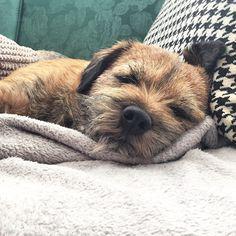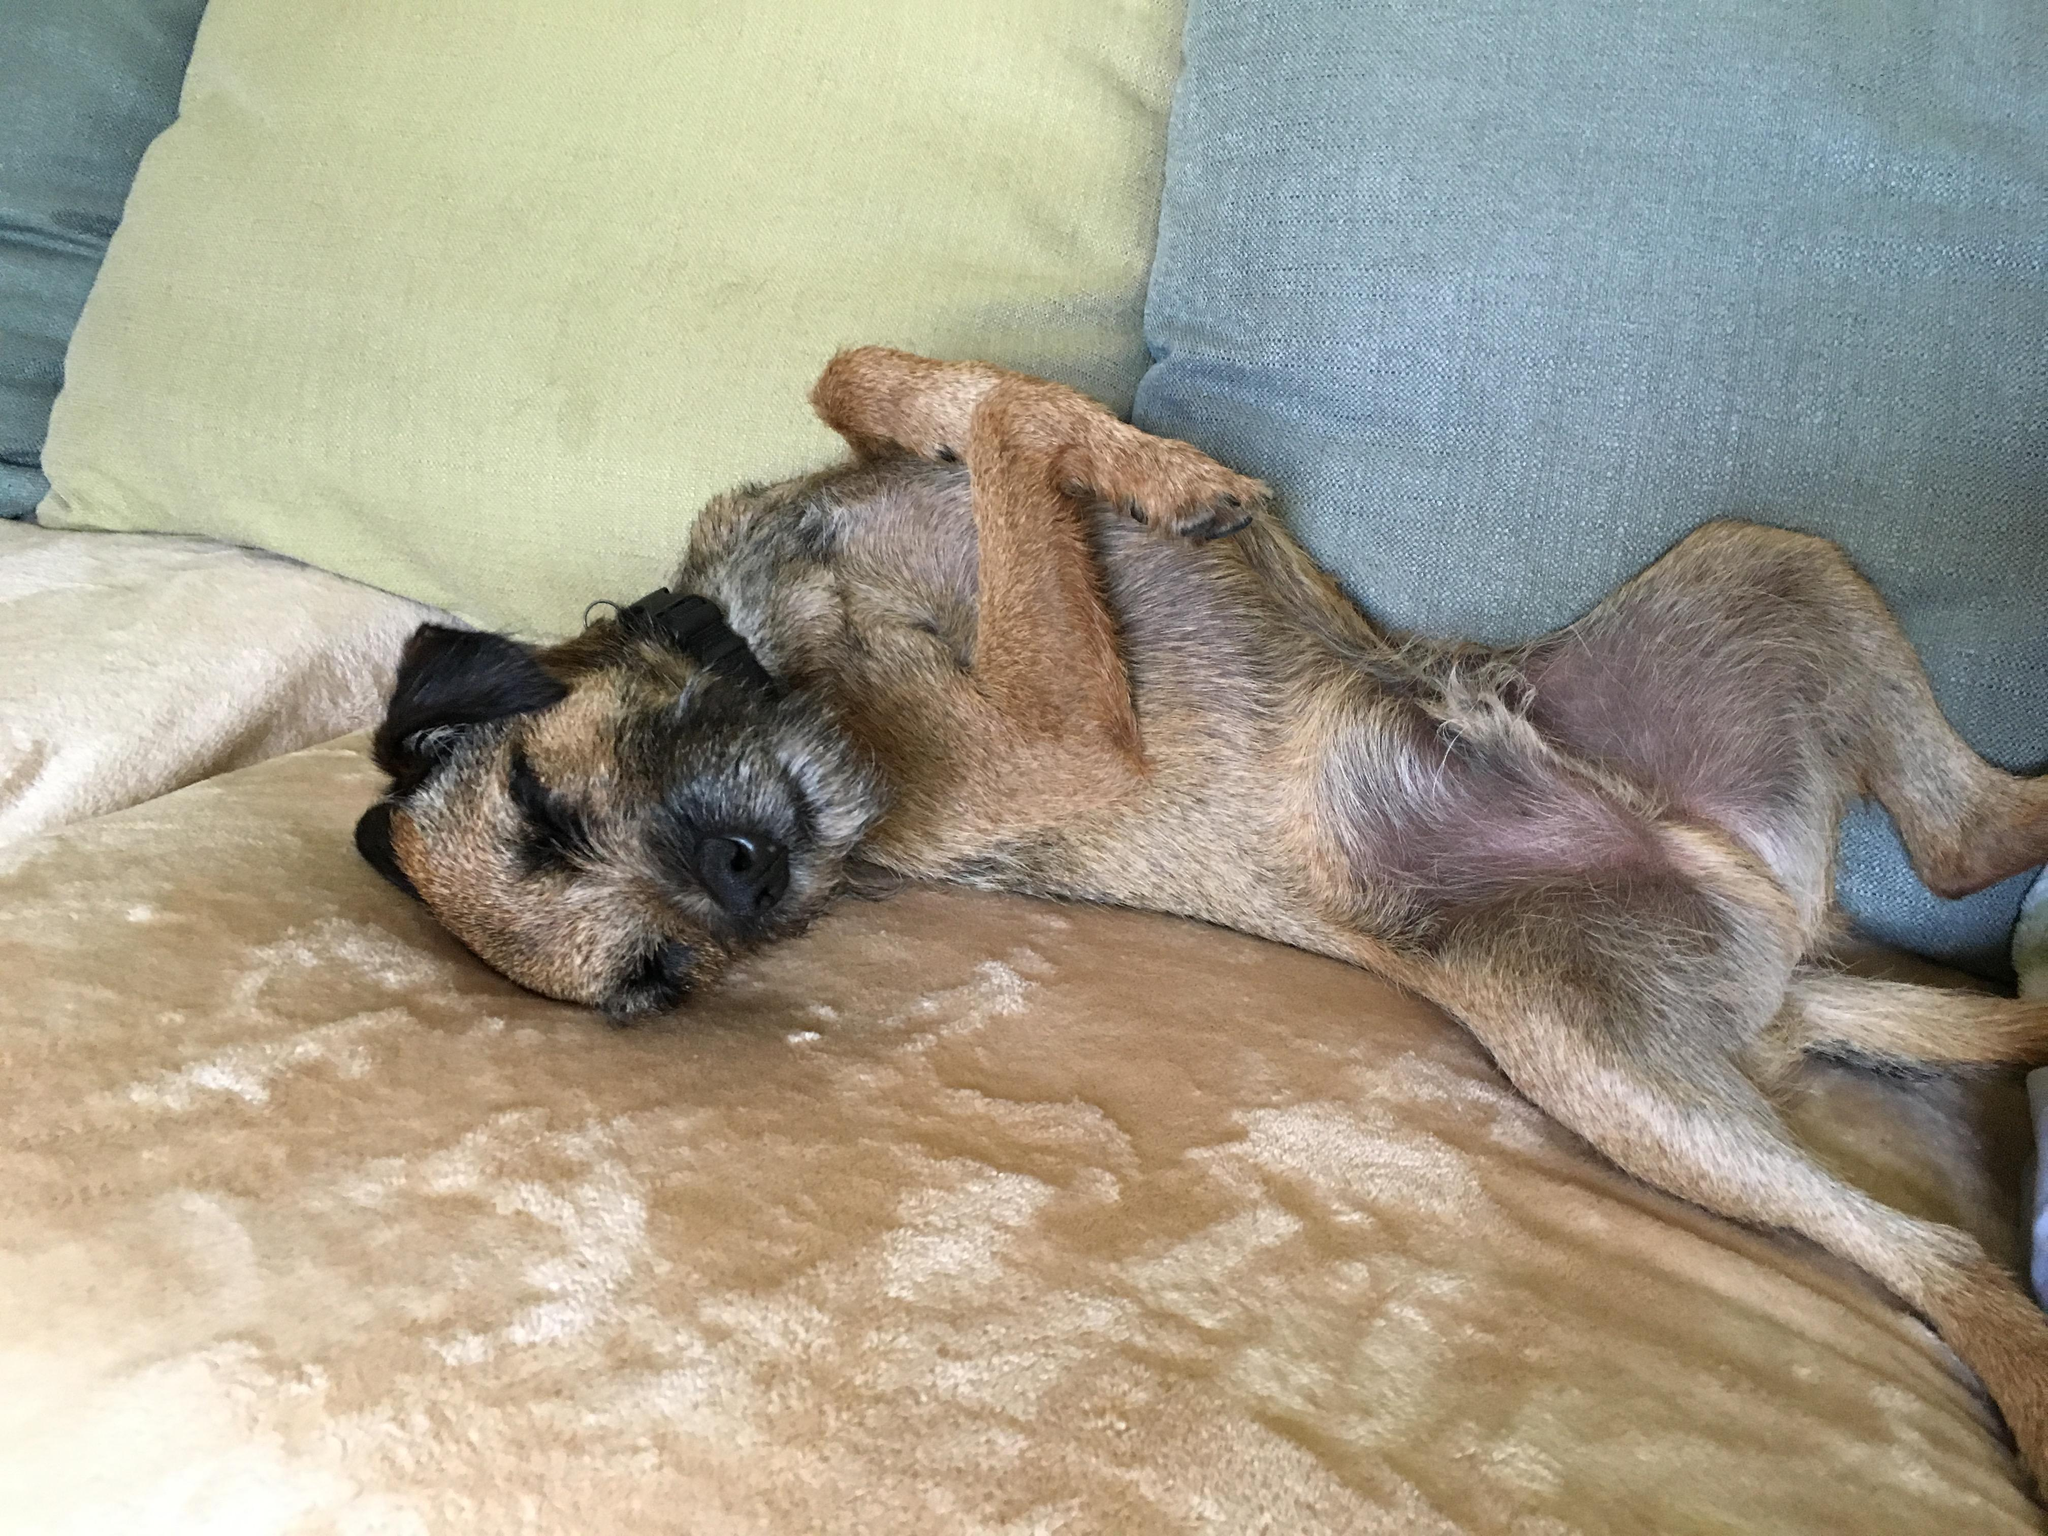The first image is the image on the left, the second image is the image on the right. For the images displayed, is the sentence "There are three dogs sleeping" factually correct? Answer yes or no. No. The first image is the image on the left, the second image is the image on the right. Given the left and right images, does the statement "One image shows two dogs snoozing together." hold true? Answer yes or no. No. 